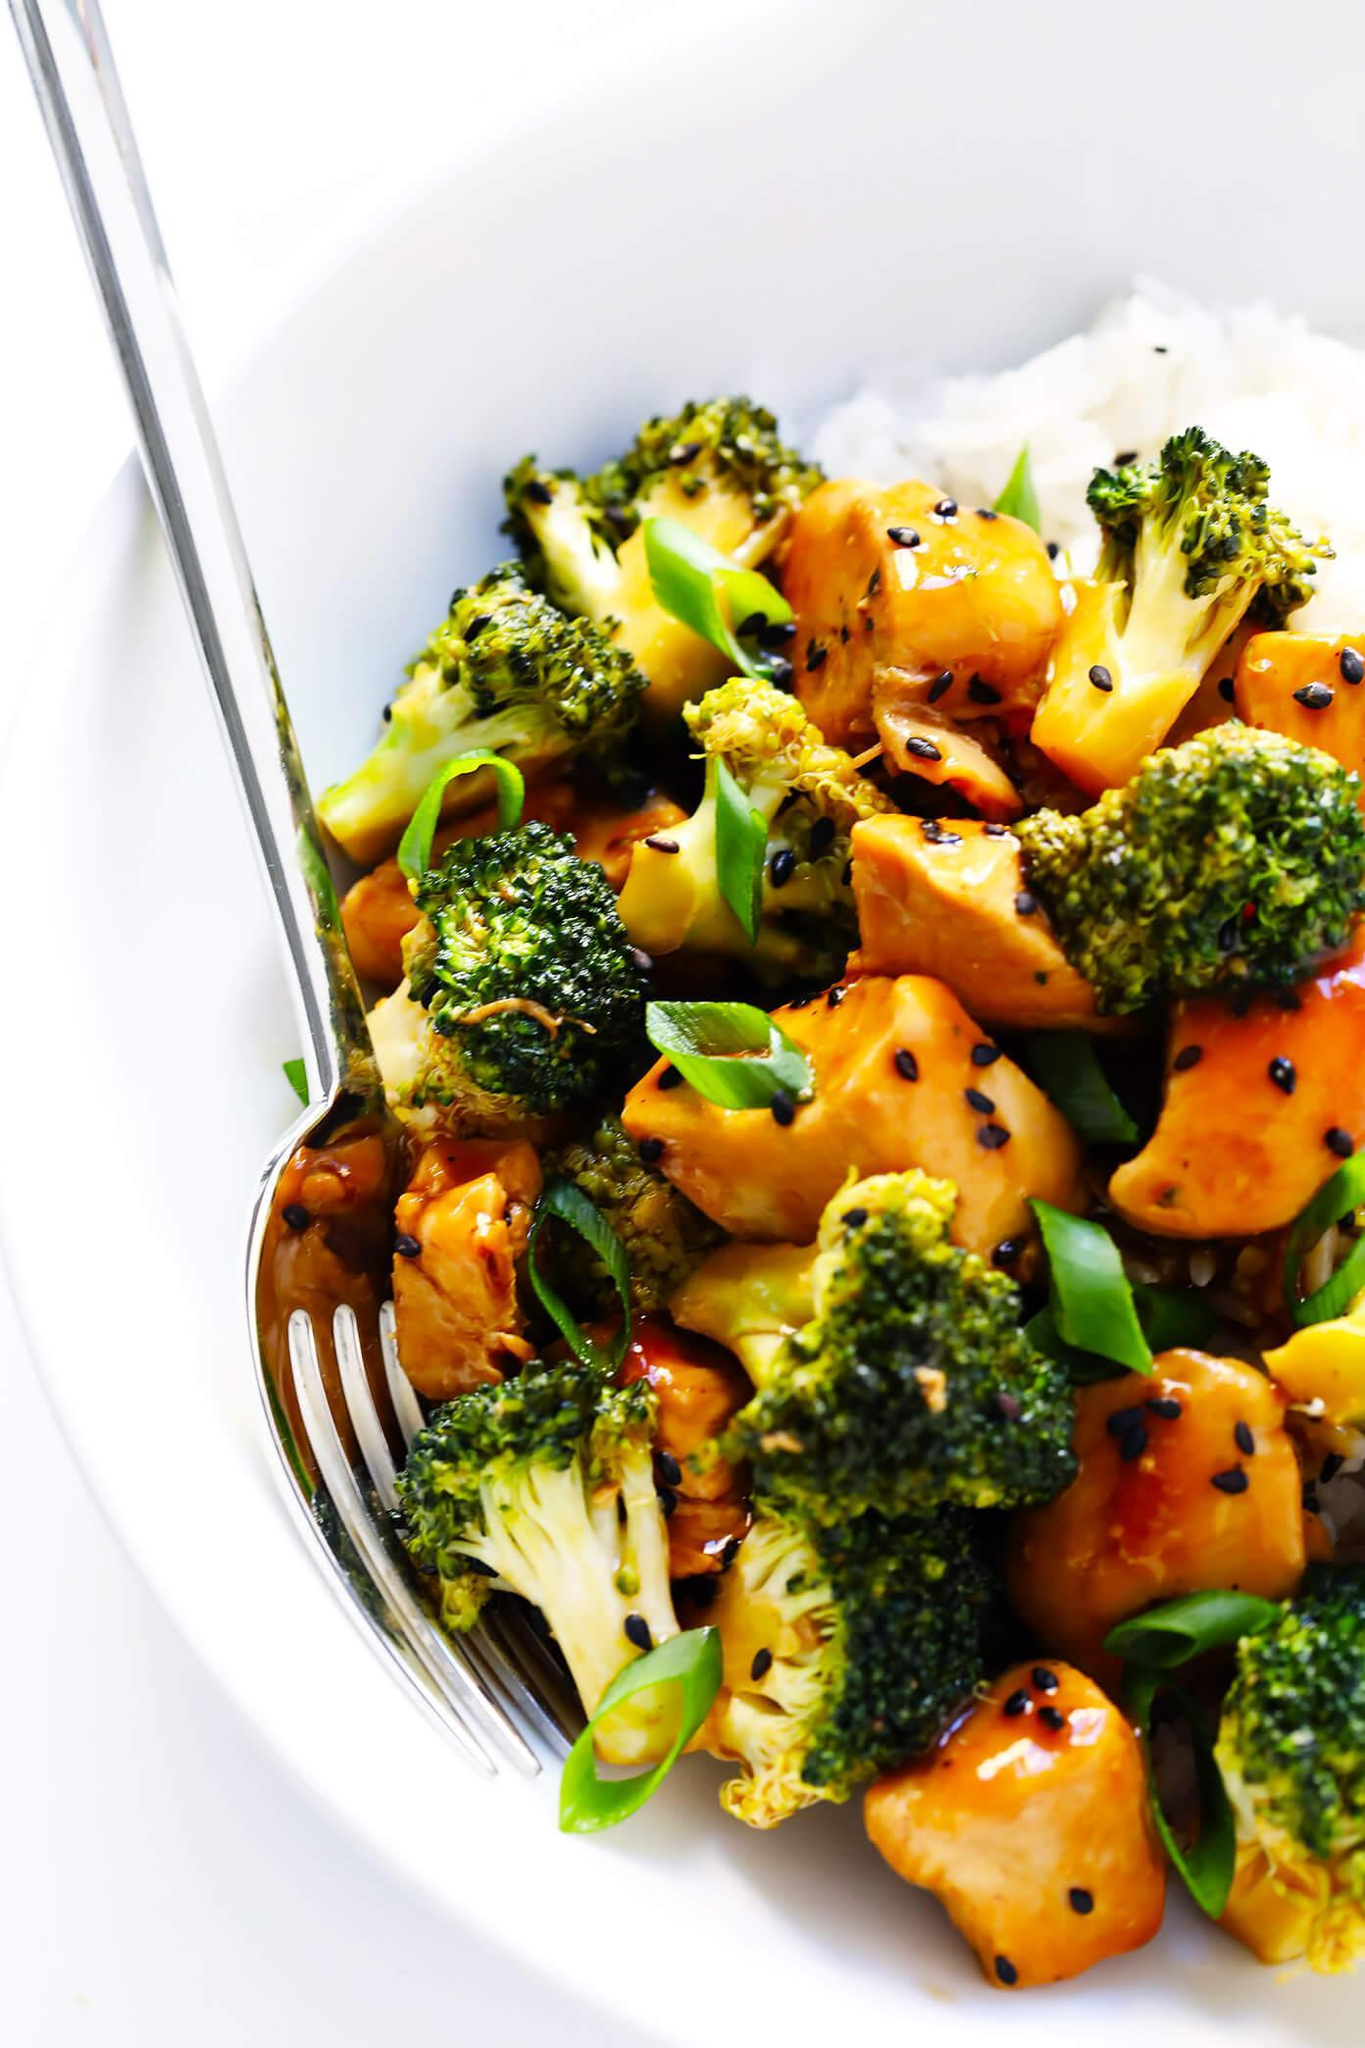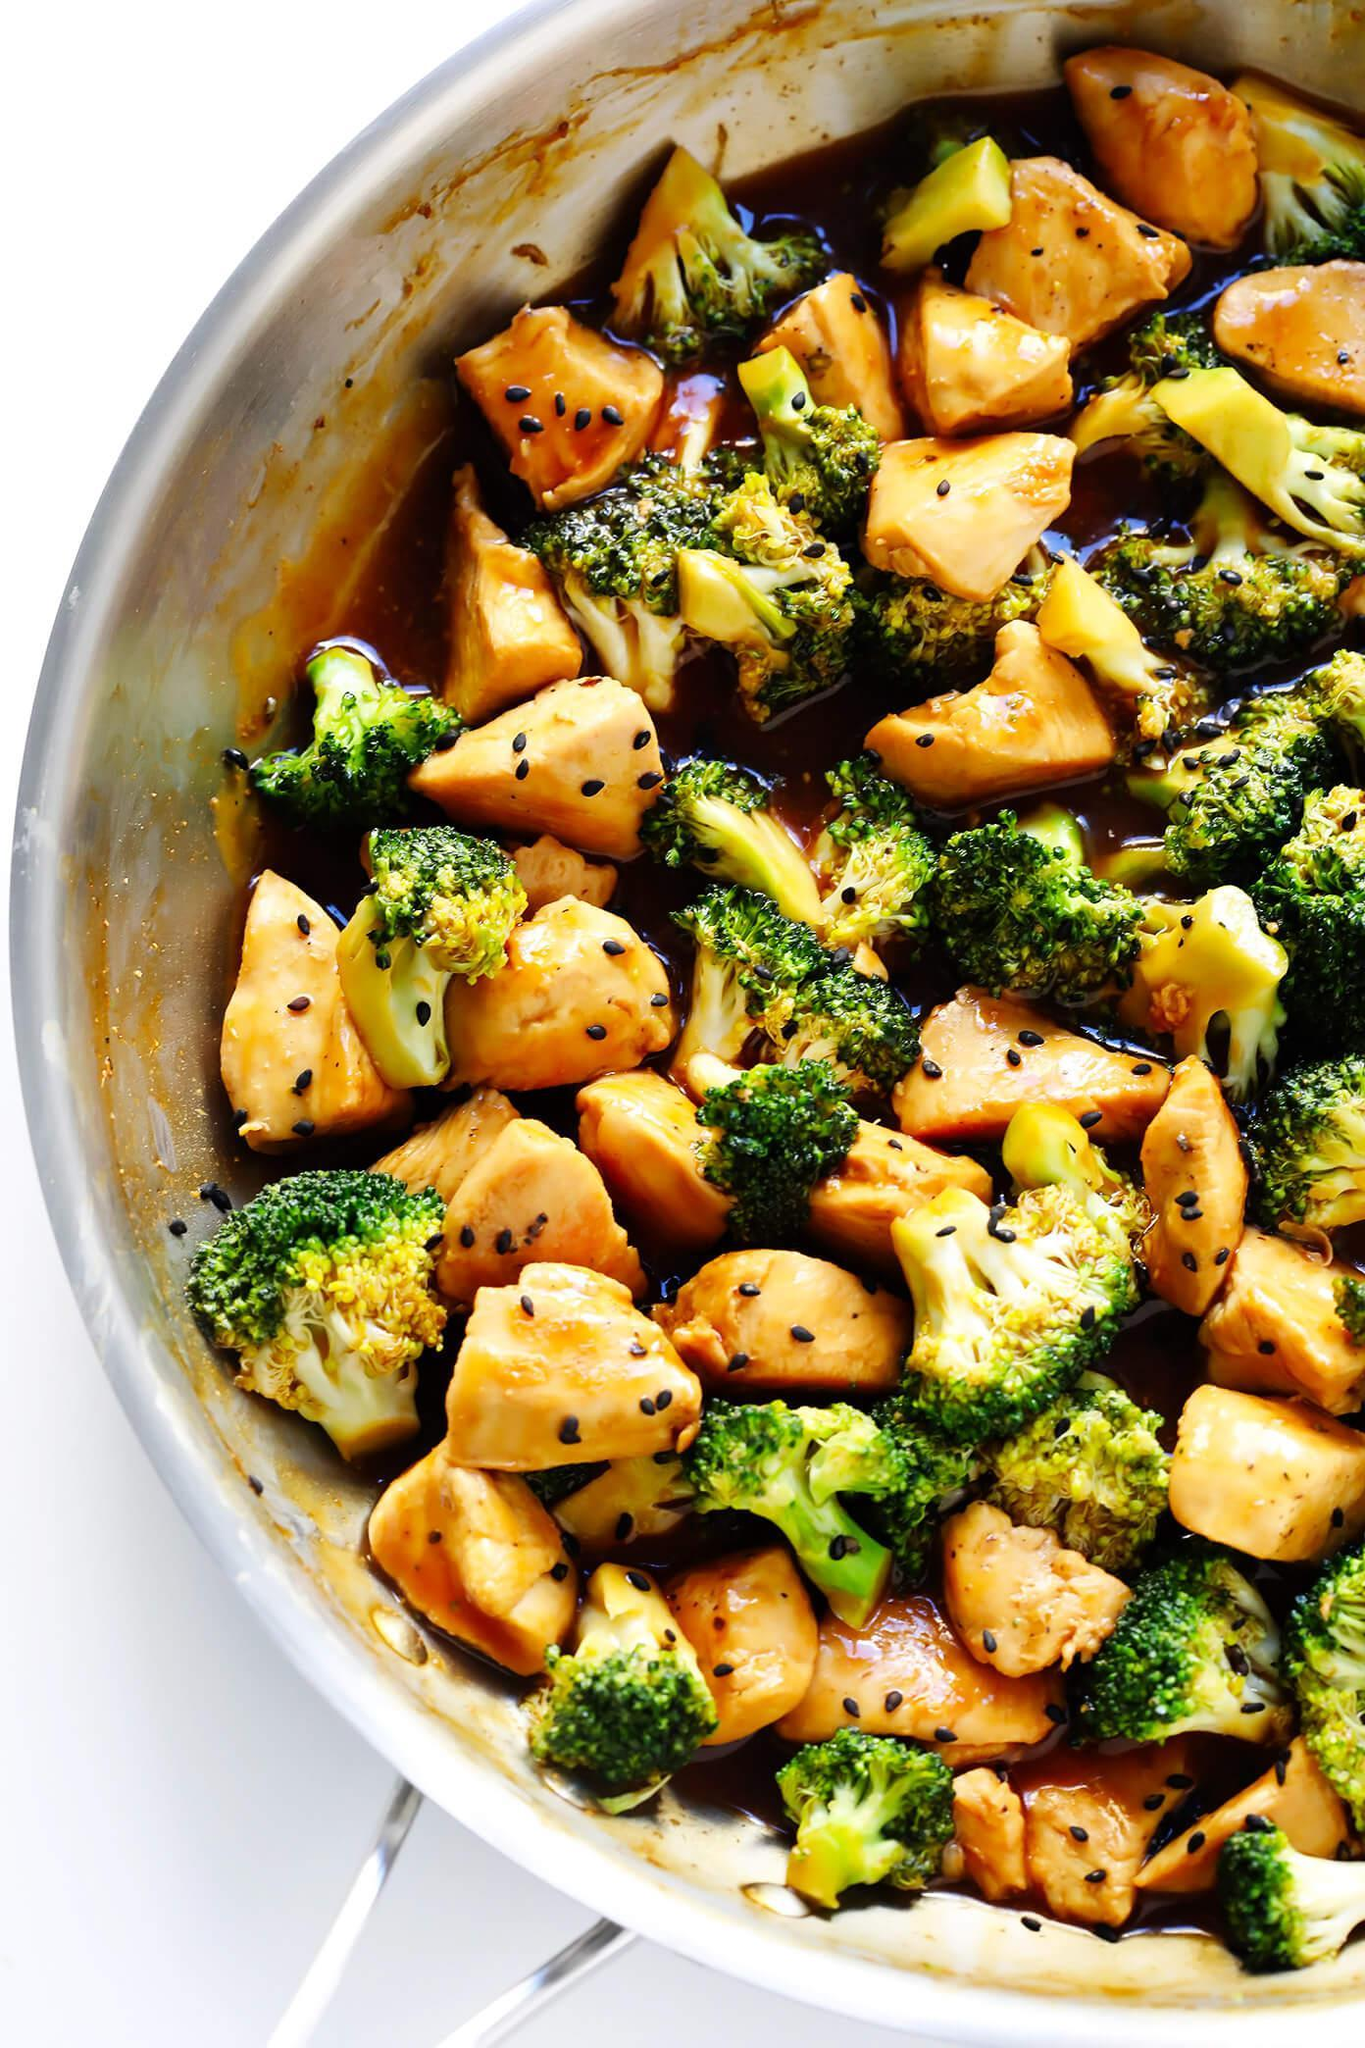The first image is the image on the left, the second image is the image on the right. Considering the images on both sides, is "A fork is inside the bowl of one of the stir-frys in one image." valid? Answer yes or no. Yes. The first image is the image on the left, the second image is the image on the right. Examine the images to the left and right. Is the description "The left and right image contains two white bowl of broccoli and chickens." accurate? Answer yes or no. Yes. 